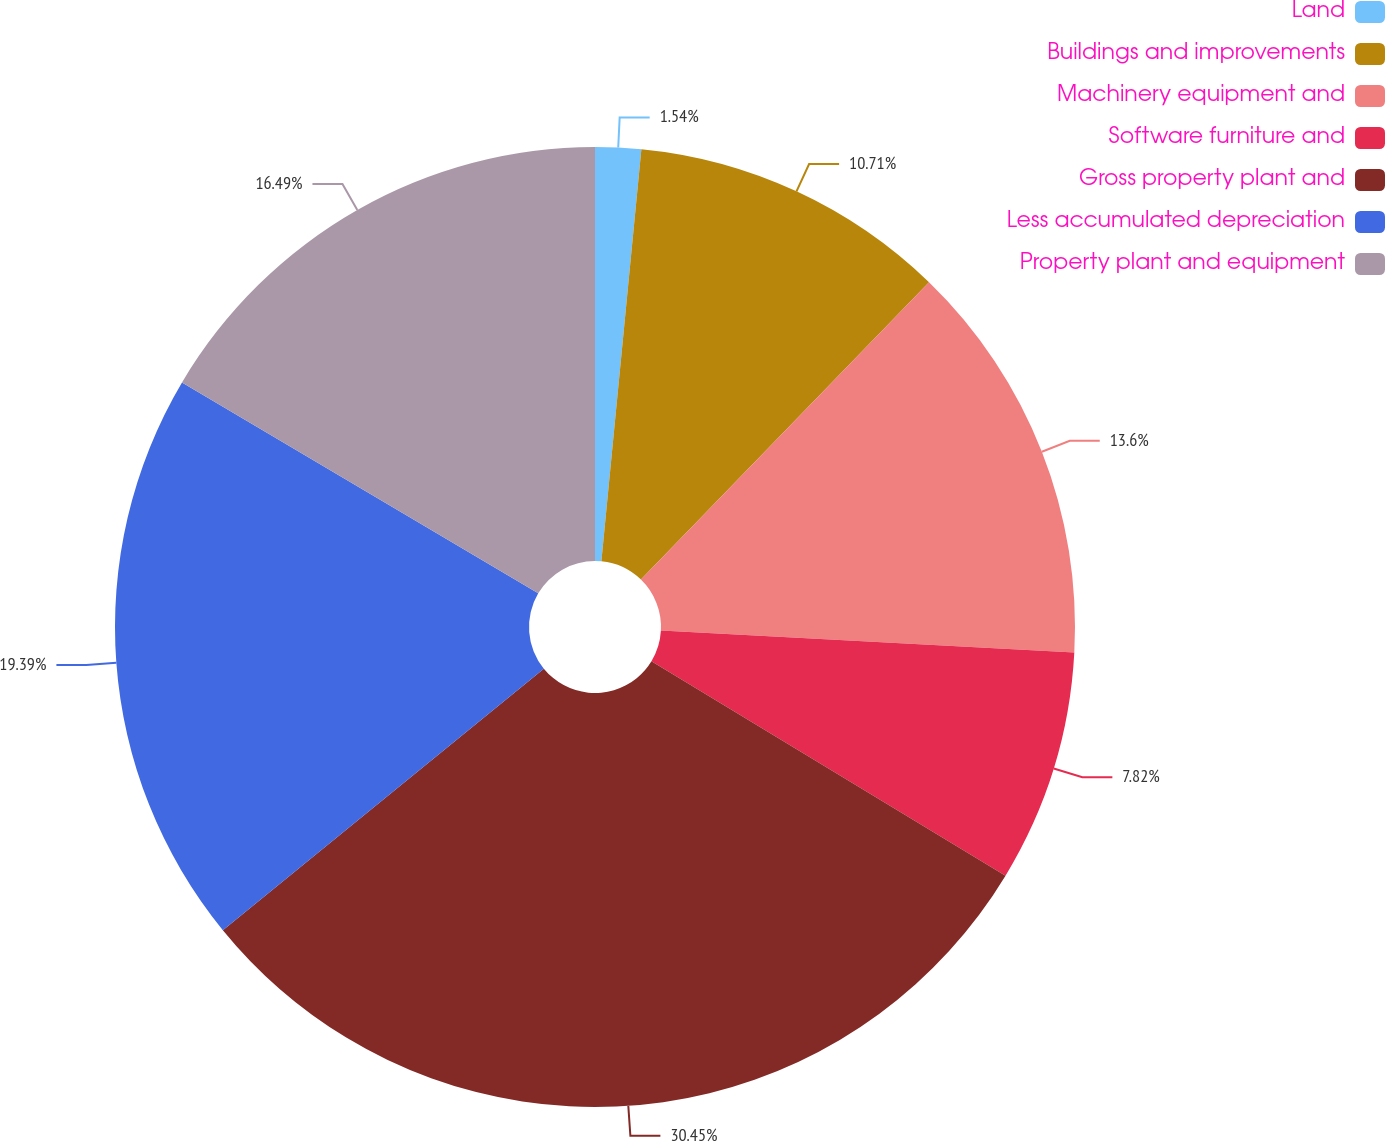Convert chart to OTSL. <chart><loc_0><loc_0><loc_500><loc_500><pie_chart><fcel>Land<fcel>Buildings and improvements<fcel>Machinery equipment and<fcel>Software furniture and<fcel>Gross property plant and<fcel>Less accumulated depreciation<fcel>Property plant and equipment<nl><fcel>1.54%<fcel>10.71%<fcel>13.6%<fcel>7.82%<fcel>30.45%<fcel>19.39%<fcel>16.49%<nl></chart> 